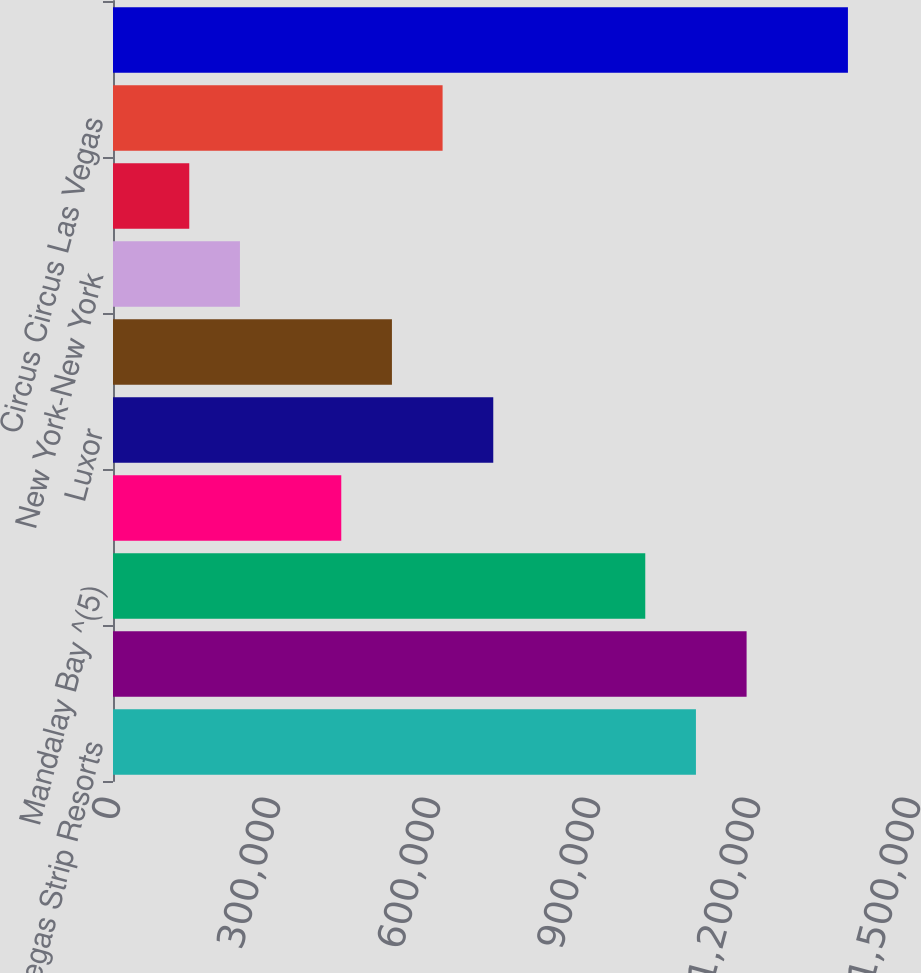<chart> <loc_0><loc_0><loc_500><loc_500><bar_chart><fcel>Las Vegas Strip Resorts<fcel>MGM Grand Las Vegas ^(4)<fcel>Mandalay Bay ^(5)<fcel>The Mirage<fcel>Luxor<fcel>Excalibur<fcel>New York-New York<fcel>Park MGM ^(6)<fcel>Circus Circus Las Vegas<fcel>Subtotal<nl><fcel>1.093e+06<fcel>1.188e+06<fcel>998000<fcel>428000<fcel>713000<fcel>523000<fcel>238000<fcel>143000<fcel>618000<fcel>1.378e+06<nl></chart> 